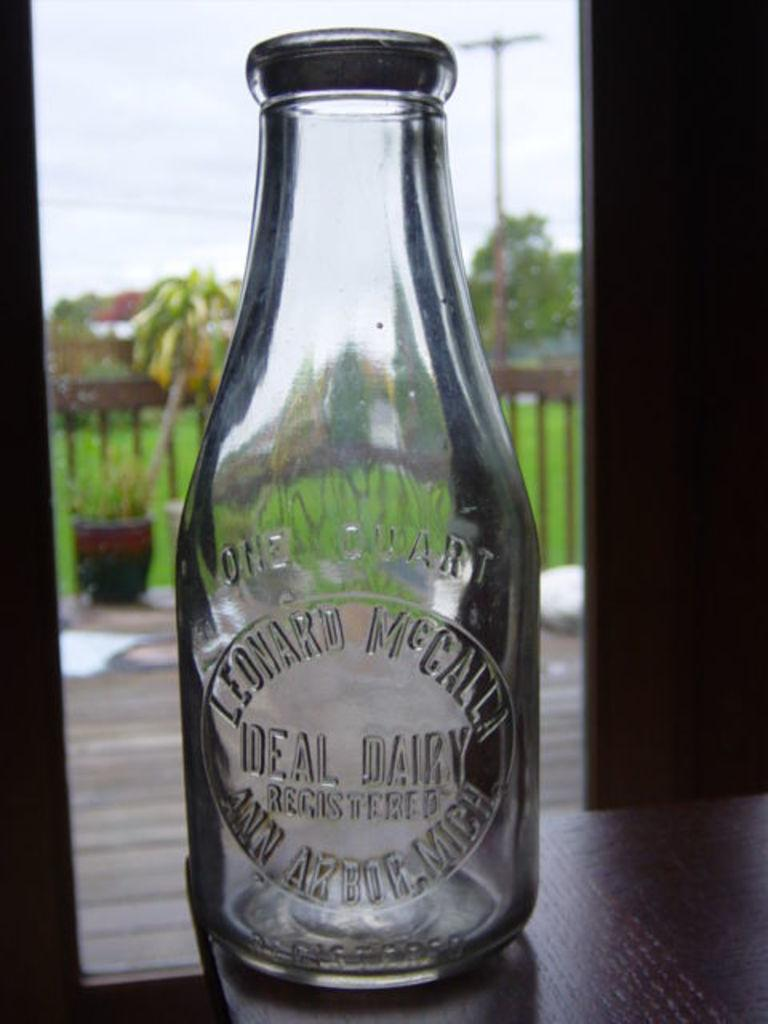What is the main object in the center of the image? There is a bottle in the center of the image. Where is the bottle located? The bottle is on a table. What can be seen in the background of the image? There is sky visible in the image, as well as a pole, plants, grass, and trees. What type of vegetable is being used as a tablecloth in the image? There is no vegetable being used as a tablecloth in the image. 